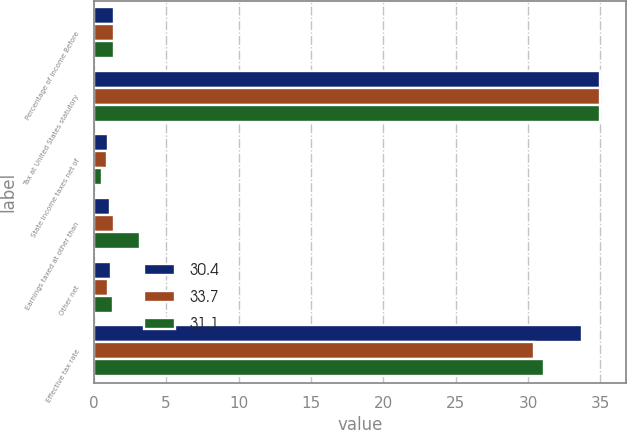Convert chart. <chart><loc_0><loc_0><loc_500><loc_500><stacked_bar_chart><ecel><fcel>Percentage of Income Before<fcel>Tax at United States statutory<fcel>State income taxes net of<fcel>Earnings taxed at other than<fcel>Other net<fcel>Effective tax rate<nl><fcel>30.4<fcel>1.4<fcel>35<fcel>1<fcel>1.1<fcel>1.2<fcel>33.7<nl><fcel>33.7<fcel>1.4<fcel>35<fcel>0.9<fcel>1.4<fcel>1<fcel>30.4<nl><fcel>31.1<fcel>1.4<fcel>35<fcel>0.6<fcel>3.2<fcel>1.3<fcel>31.1<nl></chart> 